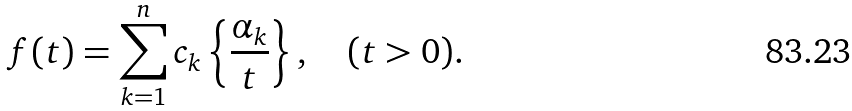Convert formula to latex. <formula><loc_0><loc_0><loc_500><loc_500>f ( t ) = \sum _ { k = 1 } ^ { n } c _ { k } \left \{ \frac { \alpha _ { k } } { t } \right \} , \quad ( t > 0 ) .</formula> 